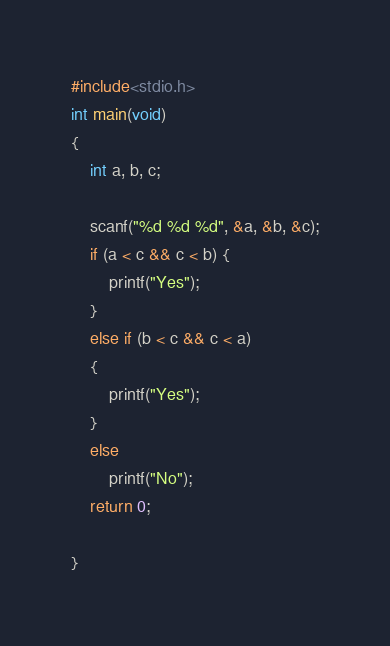Convert code to text. <code><loc_0><loc_0><loc_500><loc_500><_C_>#include<stdio.h>
int main(void)
{
	int a, b, c;

	scanf("%d %d %d", &a, &b, &c);
    if (a < c && c < b) {
        printf("Yes");
    }
    else if (b < c && c < a)
    {
        printf("Yes");
    }
    else
        printf("No");
	return 0;

}

</code> 